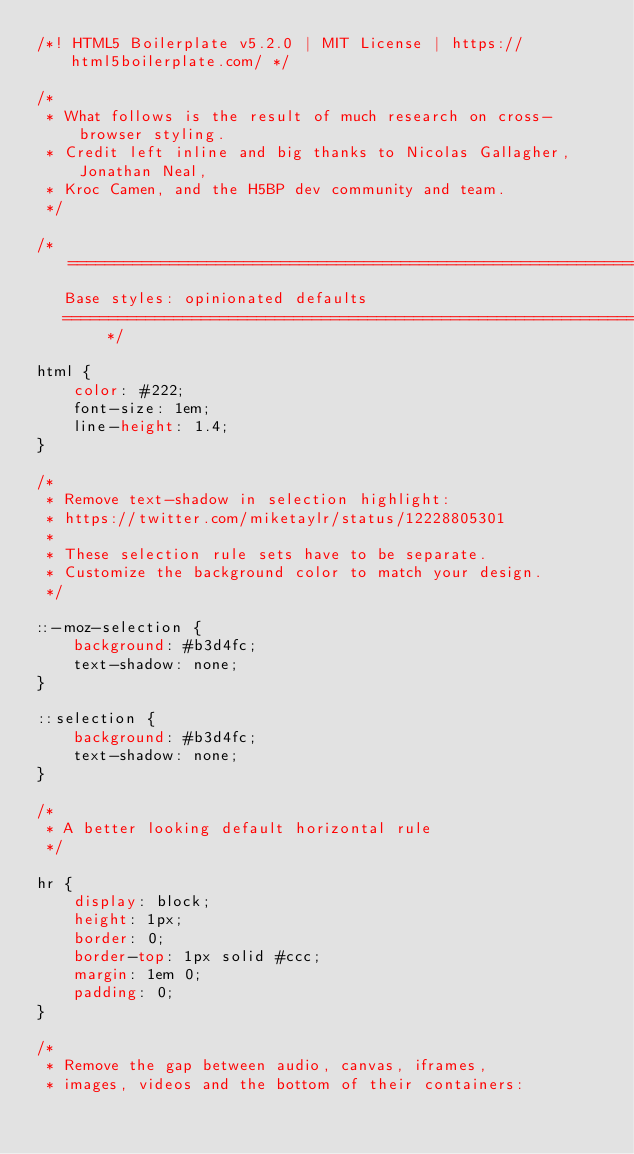Convert code to text. <code><loc_0><loc_0><loc_500><loc_500><_CSS_>/*! HTML5 Boilerplate v5.2.0 | MIT License | https://html5boilerplate.com/ */

/*
 * What follows is the result of much research on cross-browser styling.
 * Credit left inline and big thanks to Nicolas Gallagher, Jonathan Neal,
 * Kroc Camen, and the H5BP dev community and team.
 */

/* ==========================================================================
   Base styles: opinionated defaults
   ========================================================================== */

html {
    color: #222;
    font-size: 1em;
    line-height: 1.4;
}

/*
 * Remove text-shadow in selection highlight:
 * https://twitter.com/miketaylr/status/12228805301
 *
 * These selection rule sets have to be separate.
 * Customize the background color to match your design.
 */

::-moz-selection {
    background: #b3d4fc;
    text-shadow: none;
}

::selection {
    background: #b3d4fc;
    text-shadow: none;
}

/*
 * A better looking default horizontal rule
 */

hr {
    display: block;
    height: 1px;
    border: 0;
    border-top: 1px solid #ccc;
    margin: 1em 0;
    padding: 0;
}

/*
 * Remove the gap between audio, canvas, iframes,
 * images, videos and the bottom of their containers:</code> 